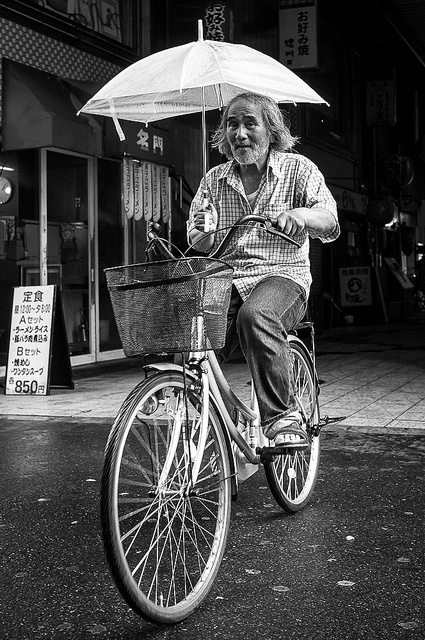Describe the objects in this image and their specific colors. I can see bicycle in black, gray, lightgray, and darkgray tones, people in black, gray, darkgray, and lightgray tones, and umbrella in black, white, darkgray, and gray tones in this image. 